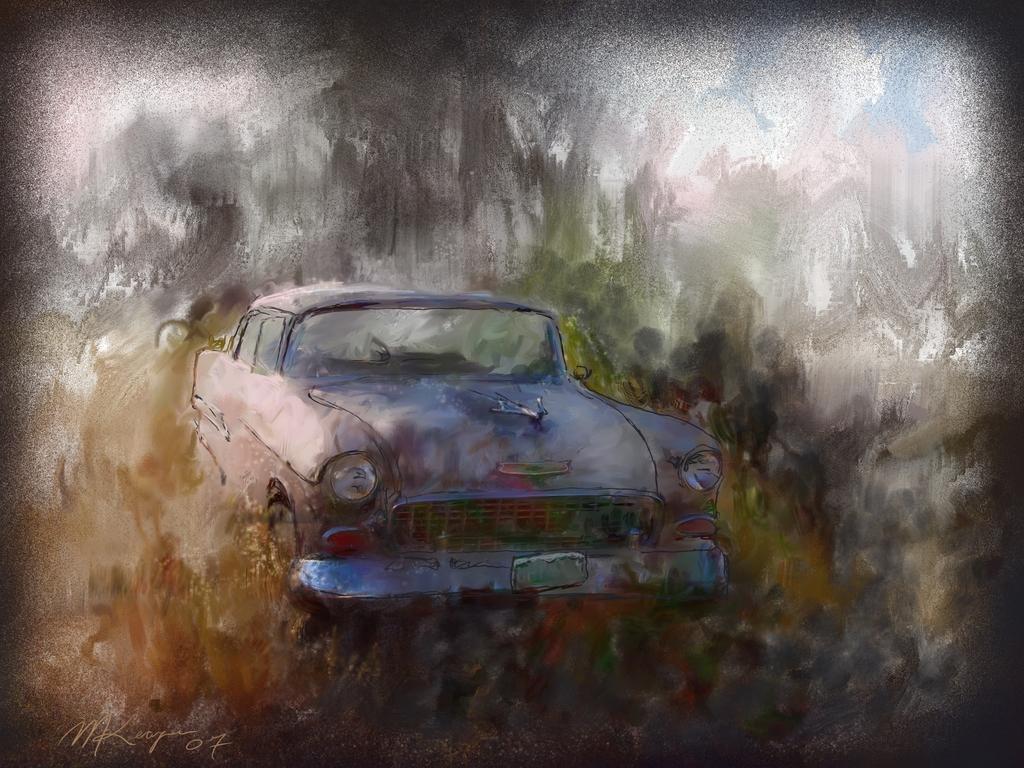In one or two sentences, can you explain what this image depicts? In this image I can see the painting in which I can see a car, few trees and the sky. 